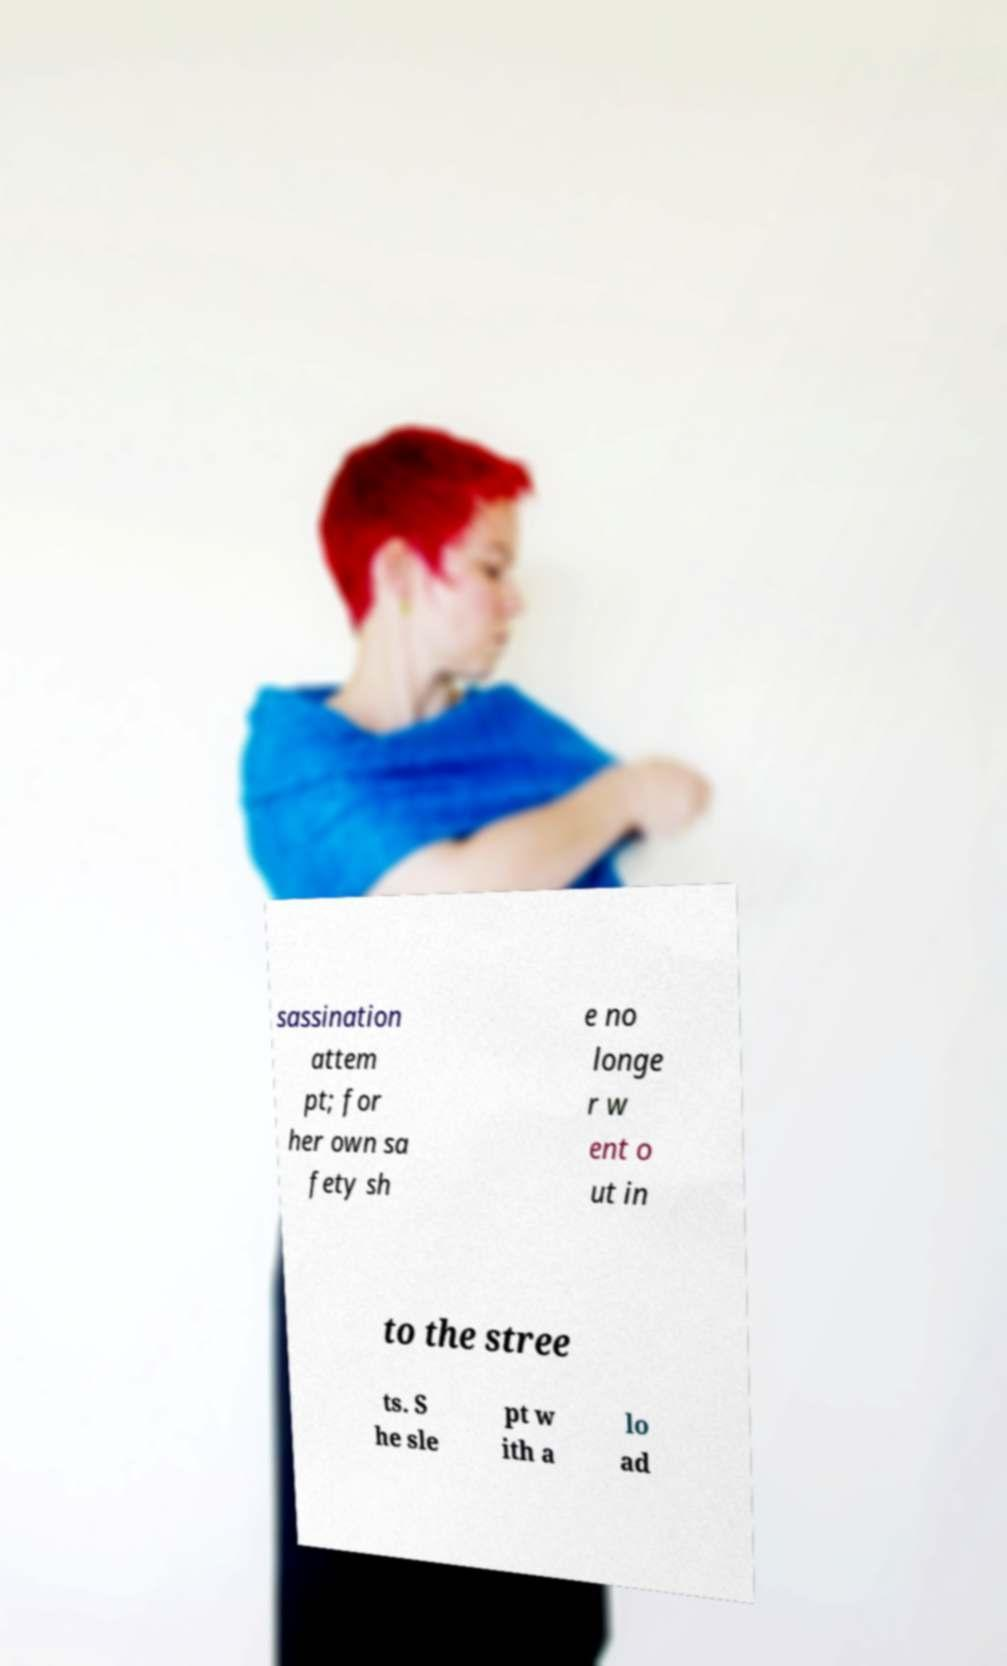I need the written content from this picture converted into text. Can you do that? sassination attem pt; for her own sa fety sh e no longe r w ent o ut in to the stree ts. S he sle pt w ith a lo ad 